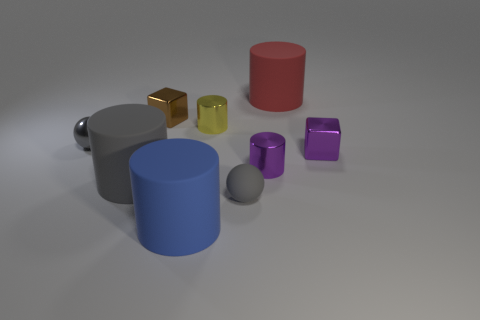Subtract all gray cylinders. How many cylinders are left? 4 Subtract all red rubber cylinders. How many cylinders are left? 4 Subtract all green cylinders. Subtract all brown cubes. How many cylinders are left? 5 Add 1 green metallic cylinders. How many objects exist? 10 Subtract all spheres. How many objects are left? 7 Subtract all large yellow balls. Subtract all red things. How many objects are left? 8 Add 2 blue rubber objects. How many blue rubber objects are left? 3 Add 4 matte things. How many matte things exist? 8 Subtract 0 blue cubes. How many objects are left? 9 